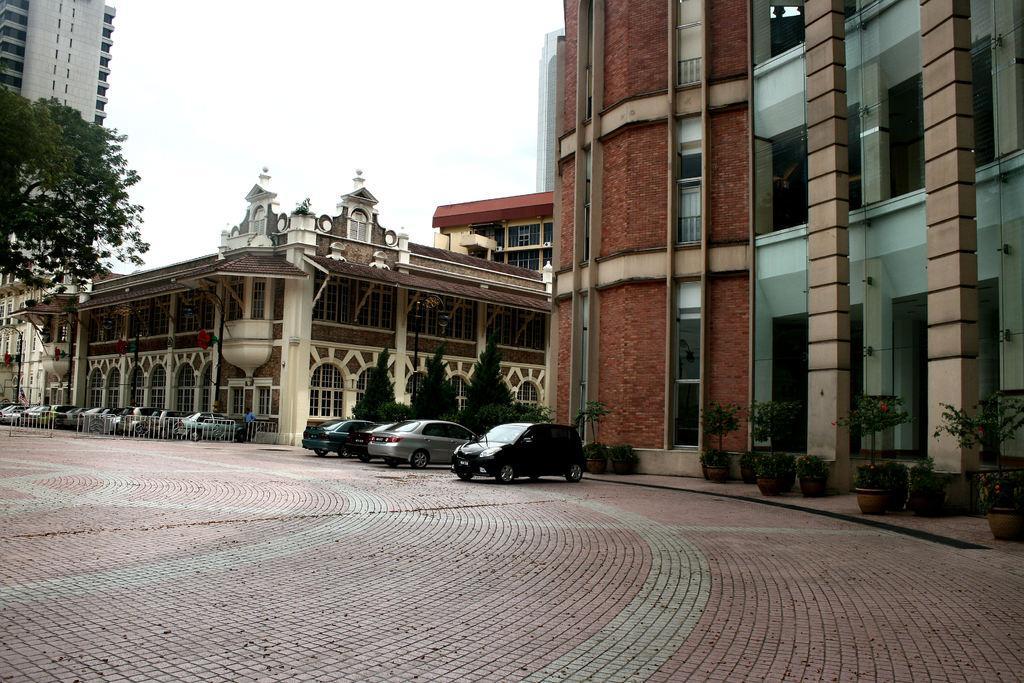Could you give a brief overview of what you see in this image? In this picture we can see three cars which is parked near to the fencing. In the top left corner there is a skyscraper. At the top we can see sky and clouds. 